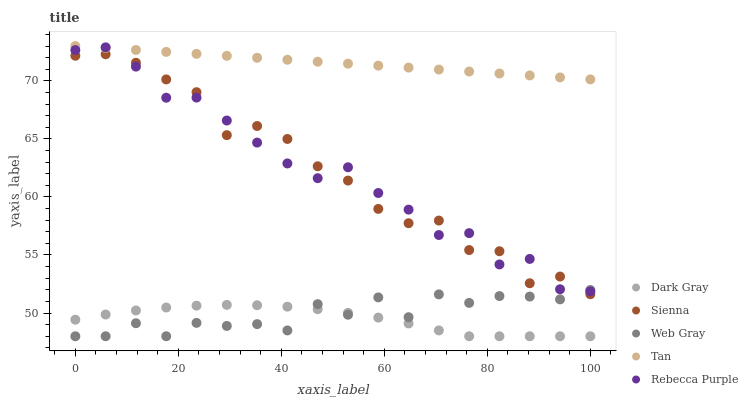Does Dark Gray have the minimum area under the curve?
Answer yes or no. Yes. Does Tan have the maximum area under the curve?
Answer yes or no. Yes. Does Sienna have the minimum area under the curve?
Answer yes or no. No. Does Sienna have the maximum area under the curve?
Answer yes or no. No. Is Tan the smoothest?
Answer yes or no. Yes. Is Sienna the roughest?
Answer yes or no. Yes. Is Sienna the smoothest?
Answer yes or no. No. Is Tan the roughest?
Answer yes or no. No. Does Dark Gray have the lowest value?
Answer yes or no. Yes. Does Sienna have the lowest value?
Answer yes or no. No. Does Tan have the highest value?
Answer yes or no. Yes. Does Sienna have the highest value?
Answer yes or no. No. Is Web Gray less than Tan?
Answer yes or no. Yes. Is Tan greater than Web Gray?
Answer yes or no. Yes. Does Sienna intersect Web Gray?
Answer yes or no. Yes. Is Sienna less than Web Gray?
Answer yes or no. No. Is Sienna greater than Web Gray?
Answer yes or no. No. Does Web Gray intersect Tan?
Answer yes or no. No. 